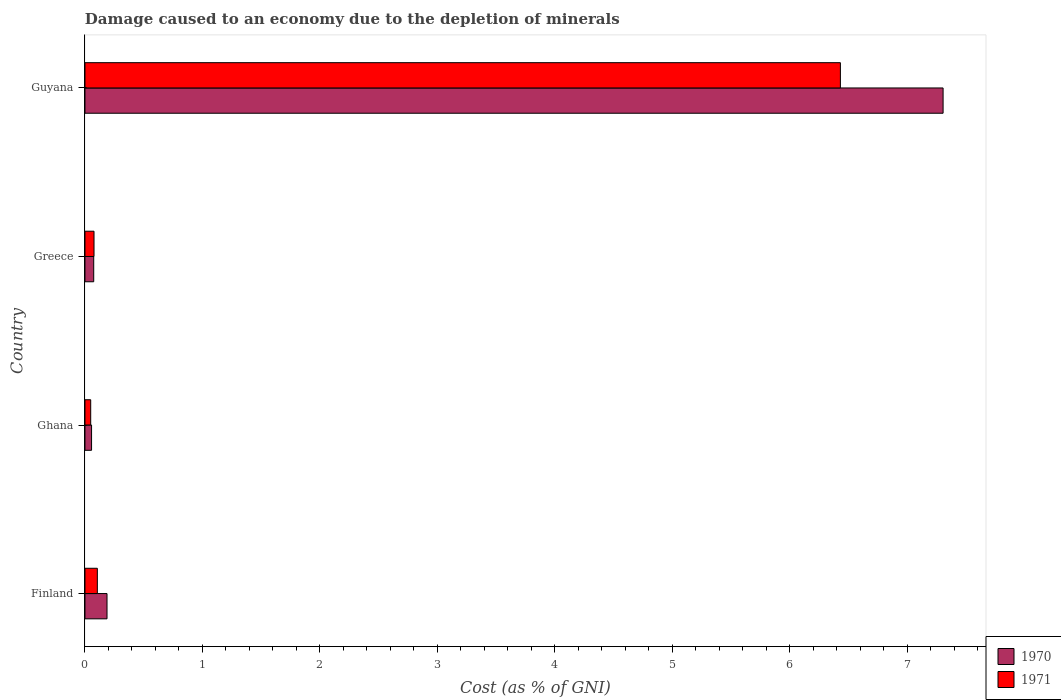Are the number of bars on each tick of the Y-axis equal?
Make the answer very short. Yes. How many bars are there on the 1st tick from the top?
Give a very brief answer. 2. How many bars are there on the 2nd tick from the bottom?
Offer a very short reply. 2. What is the label of the 1st group of bars from the top?
Your response must be concise. Guyana. In how many cases, is the number of bars for a given country not equal to the number of legend labels?
Offer a very short reply. 0. What is the cost of damage caused due to the depletion of minerals in 1971 in Greece?
Provide a succinct answer. 0.08. Across all countries, what is the maximum cost of damage caused due to the depletion of minerals in 1970?
Make the answer very short. 7.3. Across all countries, what is the minimum cost of damage caused due to the depletion of minerals in 1970?
Give a very brief answer. 0.06. In which country was the cost of damage caused due to the depletion of minerals in 1971 maximum?
Make the answer very short. Guyana. In which country was the cost of damage caused due to the depletion of minerals in 1971 minimum?
Make the answer very short. Ghana. What is the total cost of damage caused due to the depletion of minerals in 1971 in the graph?
Offer a very short reply. 6.66. What is the difference between the cost of damage caused due to the depletion of minerals in 1970 in Ghana and that in Guyana?
Your answer should be very brief. -7.25. What is the difference between the cost of damage caused due to the depletion of minerals in 1971 in Guyana and the cost of damage caused due to the depletion of minerals in 1970 in Greece?
Give a very brief answer. 6.35. What is the average cost of damage caused due to the depletion of minerals in 1970 per country?
Ensure brevity in your answer.  1.91. What is the difference between the cost of damage caused due to the depletion of minerals in 1970 and cost of damage caused due to the depletion of minerals in 1971 in Finland?
Ensure brevity in your answer.  0.08. In how many countries, is the cost of damage caused due to the depletion of minerals in 1970 greater than 1.6 %?
Give a very brief answer. 1. What is the ratio of the cost of damage caused due to the depletion of minerals in 1970 in Greece to that in Guyana?
Keep it short and to the point. 0.01. Is the cost of damage caused due to the depletion of minerals in 1971 in Ghana less than that in Greece?
Keep it short and to the point. Yes. Is the difference between the cost of damage caused due to the depletion of minerals in 1970 in Finland and Ghana greater than the difference between the cost of damage caused due to the depletion of minerals in 1971 in Finland and Ghana?
Offer a terse response. Yes. What is the difference between the highest and the second highest cost of damage caused due to the depletion of minerals in 1971?
Make the answer very short. 6.32. What is the difference between the highest and the lowest cost of damage caused due to the depletion of minerals in 1971?
Offer a very short reply. 6.38. Is the sum of the cost of damage caused due to the depletion of minerals in 1970 in Greece and Guyana greater than the maximum cost of damage caused due to the depletion of minerals in 1971 across all countries?
Your answer should be compact. Yes. What does the 1st bar from the top in Greece represents?
Make the answer very short. 1971. How many bars are there?
Your answer should be compact. 8. Are all the bars in the graph horizontal?
Your response must be concise. Yes. How are the legend labels stacked?
Your response must be concise. Vertical. What is the title of the graph?
Your answer should be compact. Damage caused to an economy due to the depletion of minerals. What is the label or title of the X-axis?
Offer a terse response. Cost (as % of GNI). What is the Cost (as % of GNI) in 1970 in Finland?
Ensure brevity in your answer.  0.19. What is the Cost (as % of GNI) in 1971 in Finland?
Your answer should be compact. 0.11. What is the Cost (as % of GNI) in 1970 in Ghana?
Your response must be concise. 0.06. What is the Cost (as % of GNI) in 1971 in Ghana?
Offer a terse response. 0.05. What is the Cost (as % of GNI) in 1970 in Greece?
Make the answer very short. 0.07. What is the Cost (as % of GNI) of 1971 in Greece?
Provide a short and direct response. 0.08. What is the Cost (as % of GNI) of 1970 in Guyana?
Offer a very short reply. 7.3. What is the Cost (as % of GNI) in 1971 in Guyana?
Ensure brevity in your answer.  6.43. Across all countries, what is the maximum Cost (as % of GNI) in 1970?
Offer a terse response. 7.3. Across all countries, what is the maximum Cost (as % of GNI) of 1971?
Provide a succinct answer. 6.43. Across all countries, what is the minimum Cost (as % of GNI) in 1970?
Your answer should be compact. 0.06. Across all countries, what is the minimum Cost (as % of GNI) in 1971?
Give a very brief answer. 0.05. What is the total Cost (as % of GNI) of 1970 in the graph?
Your answer should be compact. 7.62. What is the total Cost (as % of GNI) in 1971 in the graph?
Offer a terse response. 6.66. What is the difference between the Cost (as % of GNI) in 1970 in Finland and that in Ghana?
Ensure brevity in your answer.  0.13. What is the difference between the Cost (as % of GNI) in 1971 in Finland and that in Ghana?
Make the answer very short. 0.06. What is the difference between the Cost (as % of GNI) in 1970 in Finland and that in Greece?
Your response must be concise. 0.11. What is the difference between the Cost (as % of GNI) in 1971 in Finland and that in Greece?
Give a very brief answer. 0.03. What is the difference between the Cost (as % of GNI) in 1970 in Finland and that in Guyana?
Ensure brevity in your answer.  -7.12. What is the difference between the Cost (as % of GNI) of 1971 in Finland and that in Guyana?
Your answer should be very brief. -6.32. What is the difference between the Cost (as % of GNI) in 1970 in Ghana and that in Greece?
Your response must be concise. -0.02. What is the difference between the Cost (as % of GNI) in 1971 in Ghana and that in Greece?
Give a very brief answer. -0.03. What is the difference between the Cost (as % of GNI) in 1970 in Ghana and that in Guyana?
Provide a succinct answer. -7.25. What is the difference between the Cost (as % of GNI) of 1971 in Ghana and that in Guyana?
Provide a short and direct response. -6.38. What is the difference between the Cost (as % of GNI) in 1970 in Greece and that in Guyana?
Your answer should be very brief. -7.23. What is the difference between the Cost (as % of GNI) of 1971 in Greece and that in Guyana?
Provide a succinct answer. -6.35. What is the difference between the Cost (as % of GNI) in 1970 in Finland and the Cost (as % of GNI) in 1971 in Ghana?
Ensure brevity in your answer.  0.14. What is the difference between the Cost (as % of GNI) of 1970 in Finland and the Cost (as % of GNI) of 1971 in Greece?
Your answer should be compact. 0.11. What is the difference between the Cost (as % of GNI) of 1970 in Finland and the Cost (as % of GNI) of 1971 in Guyana?
Your response must be concise. -6.24. What is the difference between the Cost (as % of GNI) of 1970 in Ghana and the Cost (as % of GNI) of 1971 in Greece?
Your response must be concise. -0.02. What is the difference between the Cost (as % of GNI) in 1970 in Ghana and the Cost (as % of GNI) in 1971 in Guyana?
Your answer should be very brief. -6.37. What is the difference between the Cost (as % of GNI) of 1970 in Greece and the Cost (as % of GNI) of 1971 in Guyana?
Your answer should be very brief. -6.35. What is the average Cost (as % of GNI) of 1970 per country?
Your answer should be very brief. 1.91. What is the average Cost (as % of GNI) of 1971 per country?
Provide a short and direct response. 1.67. What is the difference between the Cost (as % of GNI) in 1970 and Cost (as % of GNI) in 1971 in Finland?
Ensure brevity in your answer.  0.08. What is the difference between the Cost (as % of GNI) of 1970 and Cost (as % of GNI) of 1971 in Ghana?
Ensure brevity in your answer.  0.01. What is the difference between the Cost (as % of GNI) in 1970 and Cost (as % of GNI) in 1971 in Greece?
Give a very brief answer. -0. What is the difference between the Cost (as % of GNI) of 1970 and Cost (as % of GNI) of 1971 in Guyana?
Keep it short and to the point. 0.87. What is the ratio of the Cost (as % of GNI) of 1970 in Finland to that in Ghana?
Your answer should be compact. 3.35. What is the ratio of the Cost (as % of GNI) in 1971 in Finland to that in Ghana?
Offer a terse response. 2.16. What is the ratio of the Cost (as % of GNI) in 1970 in Finland to that in Greece?
Offer a very short reply. 2.52. What is the ratio of the Cost (as % of GNI) of 1971 in Finland to that in Greece?
Your answer should be very brief. 1.37. What is the ratio of the Cost (as % of GNI) in 1970 in Finland to that in Guyana?
Offer a terse response. 0.03. What is the ratio of the Cost (as % of GNI) in 1971 in Finland to that in Guyana?
Offer a terse response. 0.02. What is the ratio of the Cost (as % of GNI) in 1970 in Ghana to that in Greece?
Your answer should be compact. 0.75. What is the ratio of the Cost (as % of GNI) in 1971 in Ghana to that in Greece?
Provide a short and direct response. 0.63. What is the ratio of the Cost (as % of GNI) in 1970 in Ghana to that in Guyana?
Provide a succinct answer. 0.01. What is the ratio of the Cost (as % of GNI) in 1971 in Ghana to that in Guyana?
Give a very brief answer. 0.01. What is the ratio of the Cost (as % of GNI) of 1970 in Greece to that in Guyana?
Your answer should be compact. 0.01. What is the ratio of the Cost (as % of GNI) in 1971 in Greece to that in Guyana?
Keep it short and to the point. 0.01. What is the difference between the highest and the second highest Cost (as % of GNI) in 1970?
Ensure brevity in your answer.  7.12. What is the difference between the highest and the second highest Cost (as % of GNI) in 1971?
Keep it short and to the point. 6.32. What is the difference between the highest and the lowest Cost (as % of GNI) in 1970?
Offer a very short reply. 7.25. What is the difference between the highest and the lowest Cost (as % of GNI) of 1971?
Ensure brevity in your answer.  6.38. 